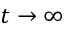Convert formula to latex. <formula><loc_0><loc_0><loc_500><loc_500>t \rightarrow \infty</formula> 